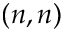Convert formula to latex. <formula><loc_0><loc_0><loc_500><loc_500>( n , n )</formula> 